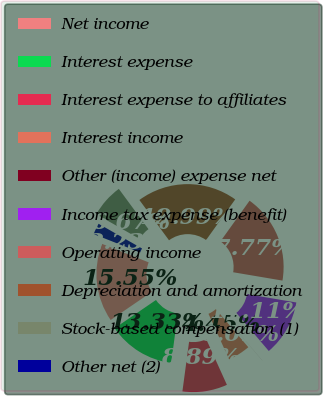Convert chart. <chart><loc_0><loc_0><loc_500><loc_500><pie_chart><fcel>Net income<fcel>Interest expense<fcel>Interest expense to affiliates<fcel>Interest income<fcel>Other (income) expense net<fcel>Income tax expense (benefit)<fcel>Operating income<fcel>Depreciation and amortization<fcel>Stock-based compensation (1)<fcel>Other net (2)<nl><fcel>15.55%<fcel>13.33%<fcel>8.89%<fcel>4.45%<fcel>0.01%<fcel>11.11%<fcel>17.77%<fcel>19.99%<fcel>6.67%<fcel>2.23%<nl></chart> 